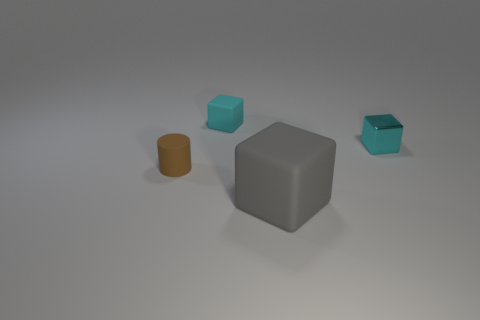There is a small matte thing that is the same color as the metallic cube; what shape is it?
Your answer should be compact. Cube. Does the object on the right side of the large gray rubber thing have the same size as the rubber cube that is behind the tiny cyan metallic thing?
Your answer should be compact. Yes. There is a matte thing that is on the right side of the tiny matte cube; what shape is it?
Your response must be concise. Cube. What is the tiny cyan object that is on the right side of the object that is in front of the tiny brown matte object made of?
Keep it short and to the point. Metal. Are there any matte cylinders that have the same color as the big cube?
Offer a very short reply. No. There is a gray object; is its size the same as the brown cylinder on the left side of the big gray cube?
Keep it short and to the point. No. There is a small rubber object on the left side of the tiny cyan block on the left side of the metallic cube; how many matte blocks are in front of it?
Offer a very short reply. 1. What number of big gray blocks are on the right side of the brown object?
Ensure brevity in your answer.  1. What color is the tiny block to the right of the thing that is in front of the brown rubber thing?
Ensure brevity in your answer.  Cyan. How many other things are made of the same material as the cylinder?
Make the answer very short. 2. 